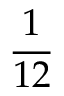<formula> <loc_0><loc_0><loc_500><loc_500>\frac { 1 } { 1 2 }</formula> 